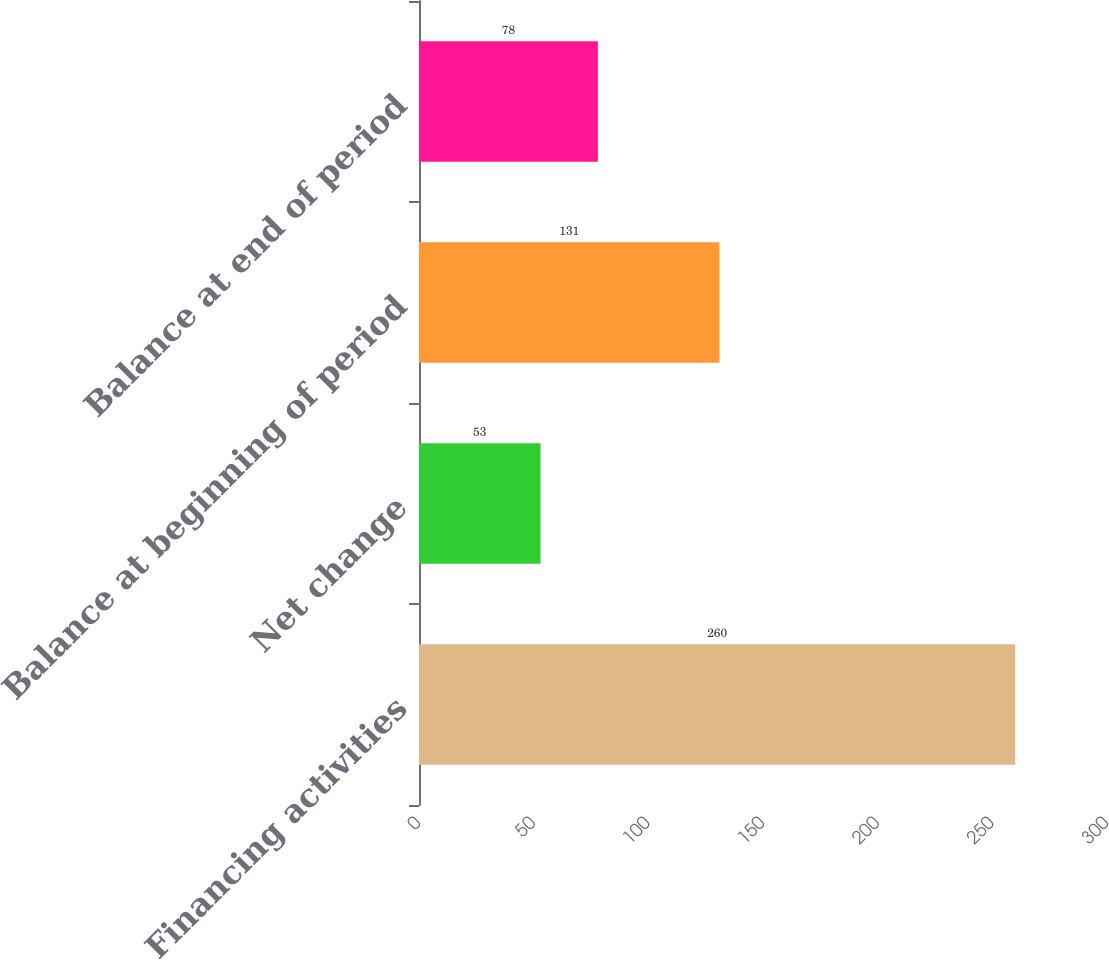Convert chart to OTSL. <chart><loc_0><loc_0><loc_500><loc_500><bar_chart><fcel>Financing activities<fcel>Net change<fcel>Balance at beginning of period<fcel>Balance at end of period<nl><fcel>260<fcel>53<fcel>131<fcel>78<nl></chart> 